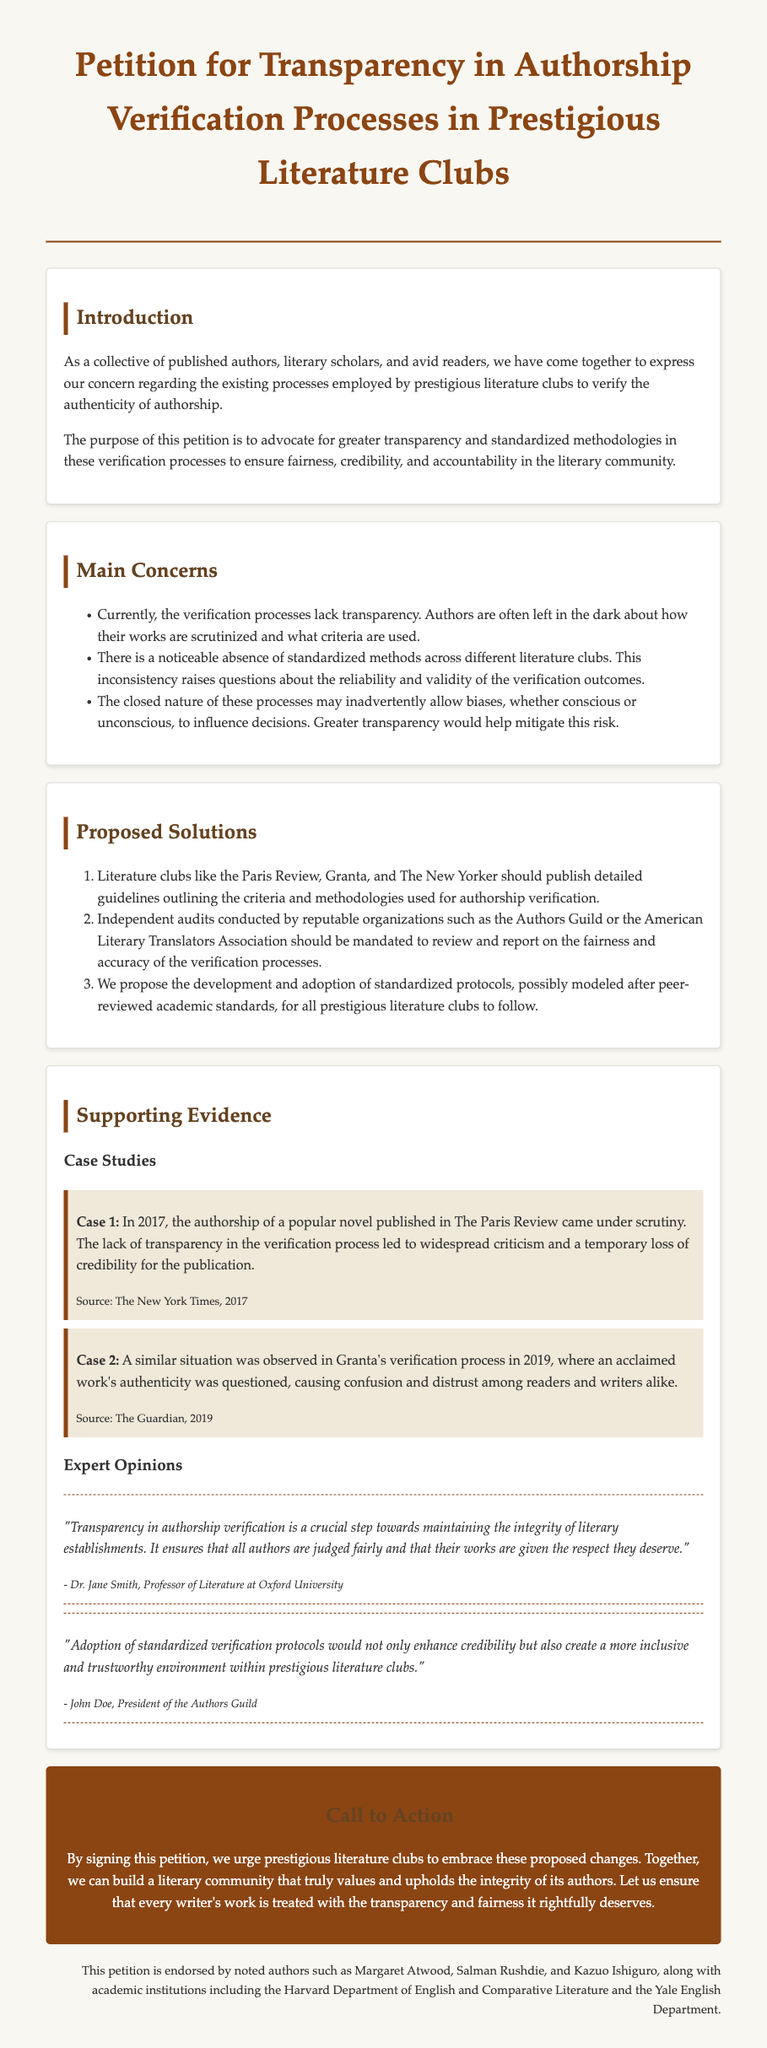What is the title of the petition? The title is explicitly stated at the top of the document as the main heading.
Answer: Petition for Transparency in Authorship Verification Processes in Prestigious Literature Clubs Who are the intended recipients of the petition? The petition addresses literature clubs, particularly prestigious ones mentioned in the document.
Answer: Literature clubs What year did the authorship scrutiny case in The Paris Review take place? The document states this information in the case study section.
Answer: 2017 Which organizations are suggested for conducting independent audits? The document lists these organizations to provide credibility in the review process.
Answer: Authors Guild or the American Literary Translators Association What is a proposed solution for the verification processes? The document outlines several solutions, one being the publication of detailed guidelines.
Answer: Publish detailed guidelines Who endorsed the petition? The document mentions notable authors and academic institutions that support the petition.
Answer: Margaret Atwood, Salman Rushdie, and Kazuo Ishiguro According to Dr. Jane Smith, what is a crucial step towards maintaining literary integrity? The document quotes Dr. Smith on the necessity of a specific process to maintain integrity within literary establishments.
Answer: Transparency in authorship verification What does the petition urge prestigious literature clubs to embrace? The petition specifically calls for these clubs to take action on the proposed changes for transparency.
Answer: Proposed changes What type of document is this? The structure and content are characteristic of an appeal for change within a community, specifically in literature.
Answer: Petition 